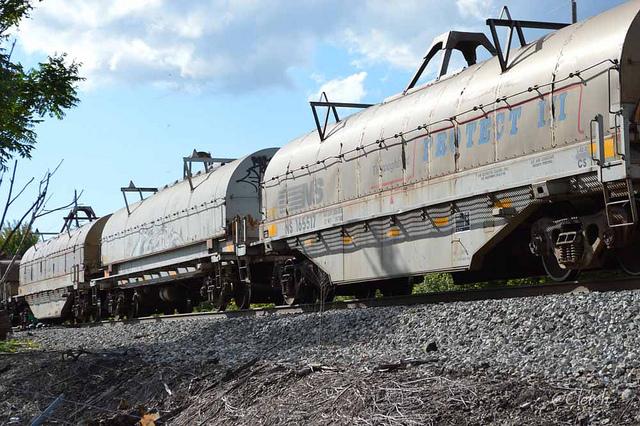Is there anyone in this train?
Answer briefly. No. How many train carts do you see?
Write a very short answer. 3. Is this a passenger train?
Write a very short answer. No. 